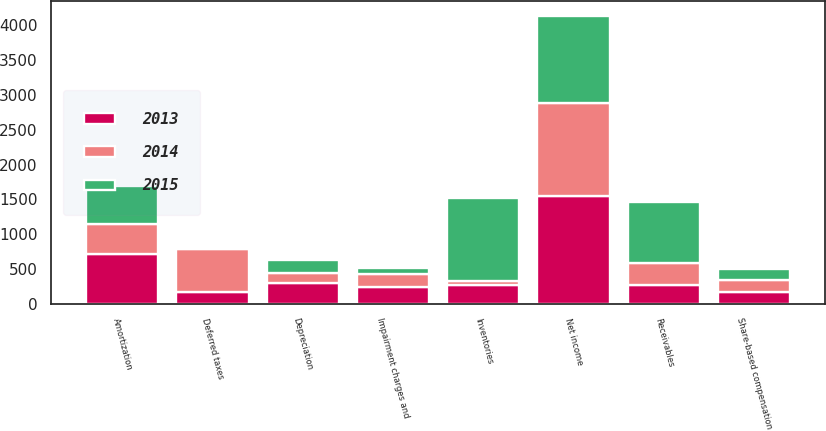Convert chart. <chart><loc_0><loc_0><loc_500><loc_500><stacked_bar_chart><ecel><fcel>Net income<fcel>Depreciation<fcel>Amortization<fcel>Deferred taxes<fcel>Share-based compensation<fcel>Impairment charges and<fcel>Receivables<fcel>Inventories<nl><fcel>2013<fcel>1543<fcel>306<fcel>711<fcel>171<fcel>174<fcel>241<fcel>273.5<fcel>273.5<nl><fcel>2015<fcel>1258<fcel>185<fcel>550<fcel>17<fcel>160<fcel>80<fcel>868<fcel>1182<nl><fcel>2014<fcel>1338<fcel>143<fcel>438<fcel>615<fcel>167<fcel>191<fcel>318<fcel>60<nl></chart> 